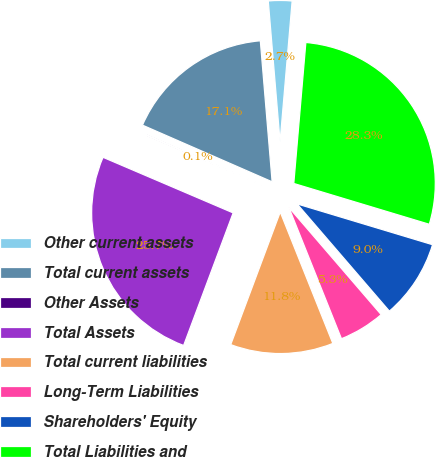<chart> <loc_0><loc_0><loc_500><loc_500><pie_chart><fcel>Other current assets<fcel>Total current assets<fcel>Other Assets<fcel>Total Assets<fcel>Total current liabilities<fcel>Long-Term Liabilities<fcel>Shareholders' Equity<fcel>Total Liabilities and<nl><fcel>2.69%<fcel>17.11%<fcel>0.13%<fcel>25.73%<fcel>11.75%<fcel>5.25%<fcel>9.03%<fcel>28.29%<nl></chart> 